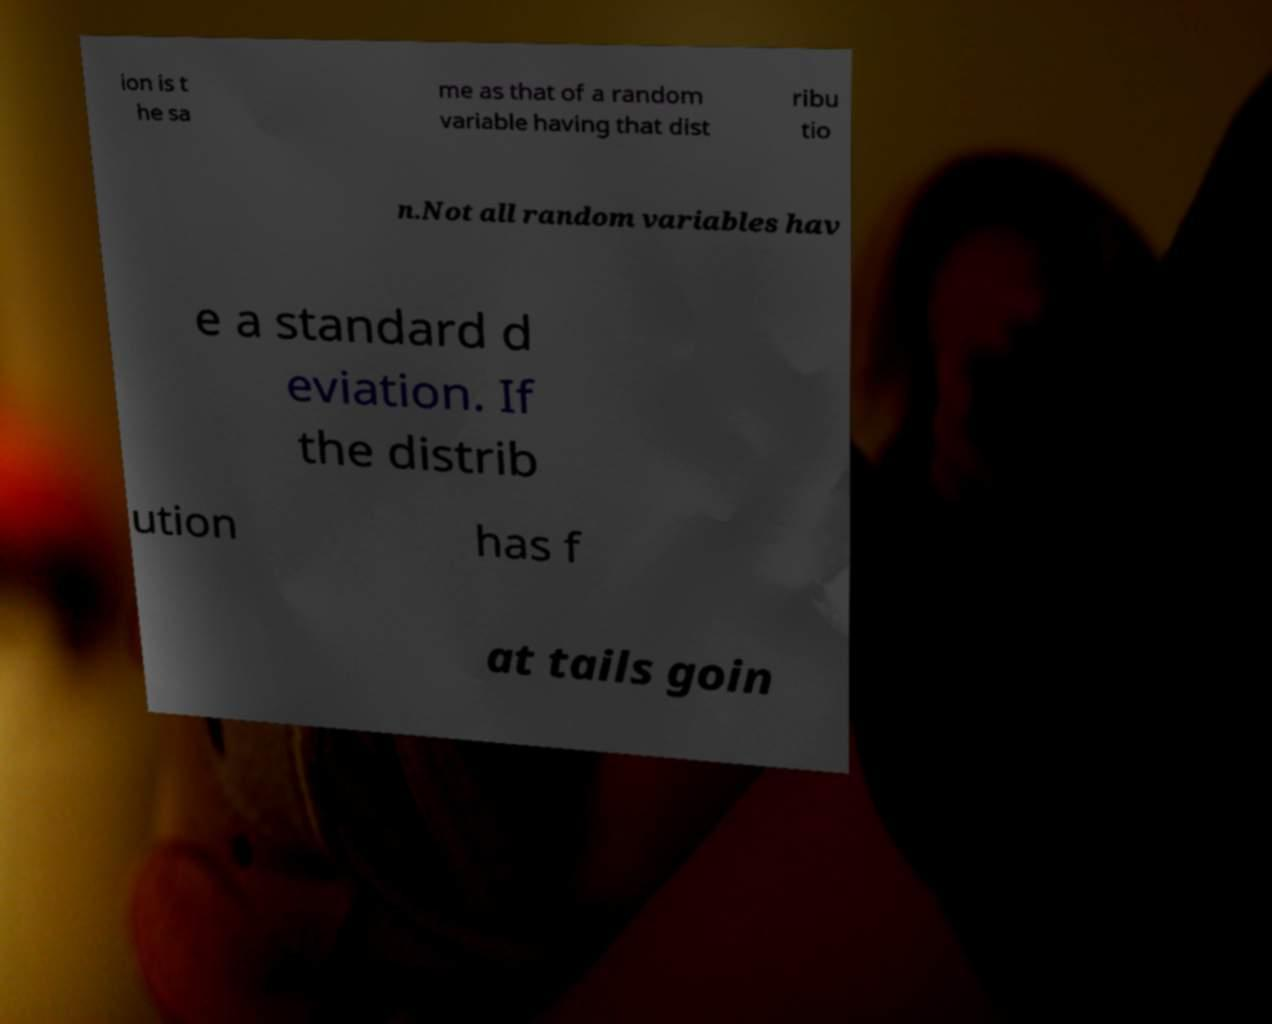Can you read and provide the text displayed in the image?This photo seems to have some interesting text. Can you extract and type it out for me? ion is t he sa me as that of a random variable having that dist ribu tio n.Not all random variables hav e a standard d eviation. If the distrib ution has f at tails goin 